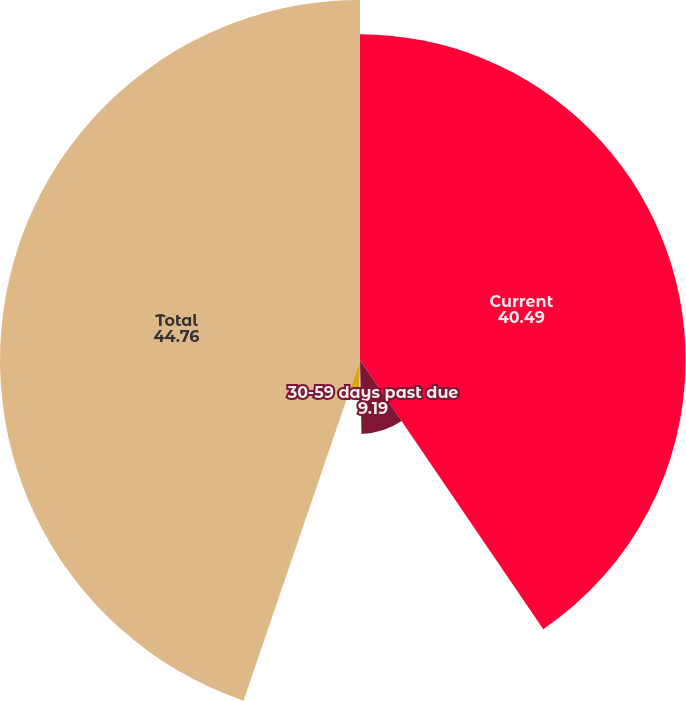<chart> <loc_0><loc_0><loc_500><loc_500><pie_chart><fcel>Current<fcel>30-59 days past due<fcel>60-89 days past due<fcel>90 days or more past due<fcel>Total<nl><fcel>40.49%<fcel>9.19%<fcel>0.65%<fcel>4.92%<fcel>44.76%<nl></chart> 